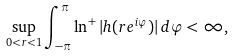Convert formula to latex. <formula><loc_0><loc_0><loc_500><loc_500>\sup _ { 0 < r < 1 } \int ^ { \pi } _ { - \pi } \ln ^ { + } | h ( r e ^ { i \varphi } ) | \, d \varphi < \infty ,</formula> 